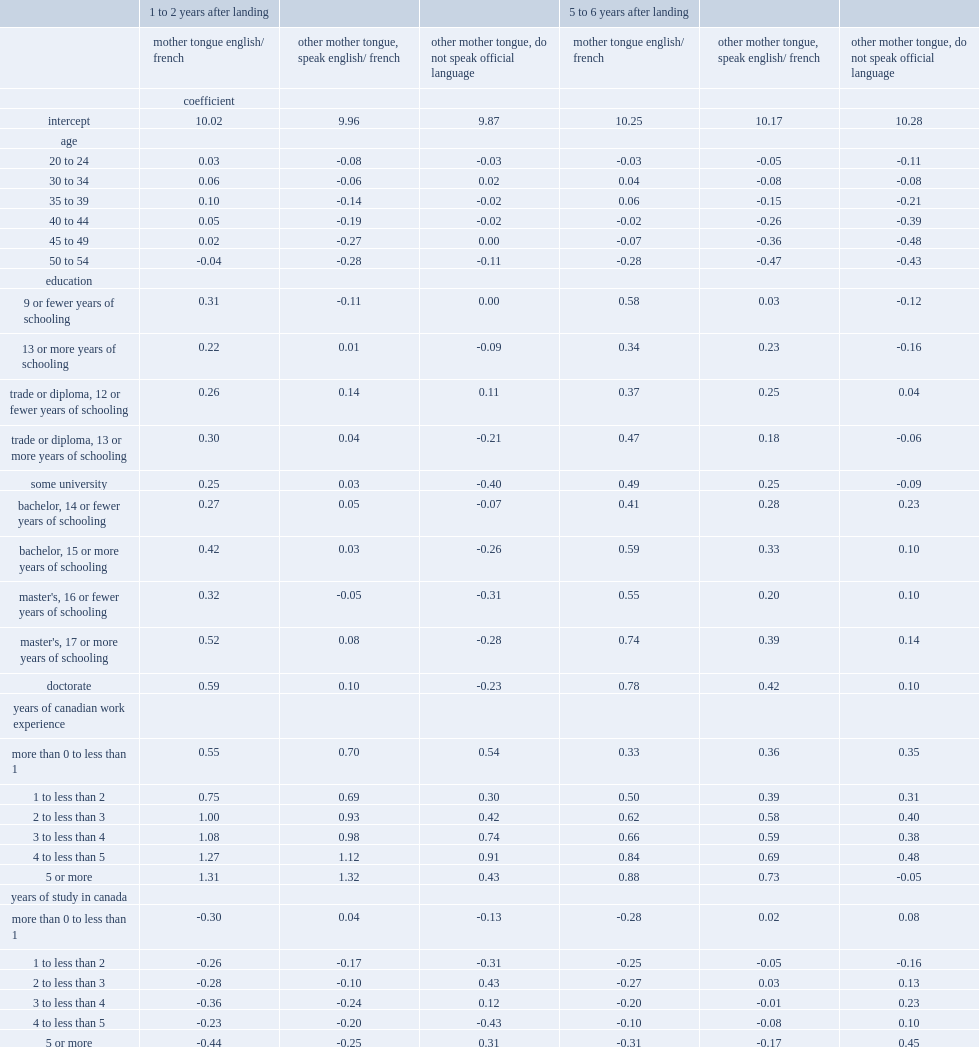What were the rates of bachelor's degree holders whose mother tongue was english or french that had entry earnings? 0.27 0.42. 